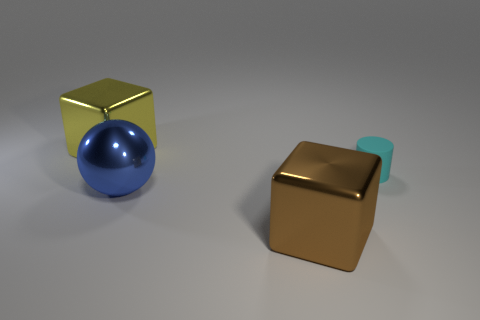There is a thing that is on the right side of the brown metallic thing; what is it made of?
Your answer should be compact. Rubber. The yellow object that is made of the same material as the ball is what size?
Ensure brevity in your answer.  Large. How many objects are big blue rubber cylinders or tiny cyan matte objects?
Offer a very short reply. 1. There is a large metal thing that is behind the small matte cylinder; what color is it?
Make the answer very short. Yellow. There is another metal object that is the same shape as the yellow metallic object; what is its size?
Your response must be concise. Large. How many things are either objects in front of the yellow block or large metal things to the right of the large yellow shiny thing?
Offer a very short reply. 3. There is a thing that is on the right side of the blue metal ball and to the left of the cylinder; what size is it?
Give a very brief answer. Large. There is a large brown shiny thing; is it the same shape as the metallic thing that is behind the tiny matte cylinder?
Offer a terse response. Yes. What number of objects are big metal things that are in front of the blue thing or big rubber things?
Offer a terse response. 1. Do the large sphere and the thing on the right side of the brown block have the same material?
Offer a very short reply. No. 